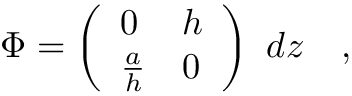<formula> <loc_0><loc_0><loc_500><loc_500>\Phi = \left ( \begin{array} { l l } { 0 } & { h } \\ { { { \frac { a } { h } } } } & { 0 } \end{array} \right ) d z \quad ,</formula> 